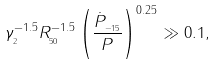Convert formula to latex. <formula><loc_0><loc_0><loc_500><loc_500>\gamma _ { _ { 2 } } ^ { - 1 . 5 } R _ { _ { 5 0 } } ^ { - 1 . 5 } \left ( \frac { \dot { P } _ { _ { - 1 5 } } } { P } \right ) ^ { 0 . 2 5 } \gg 0 . 1 ,</formula> 